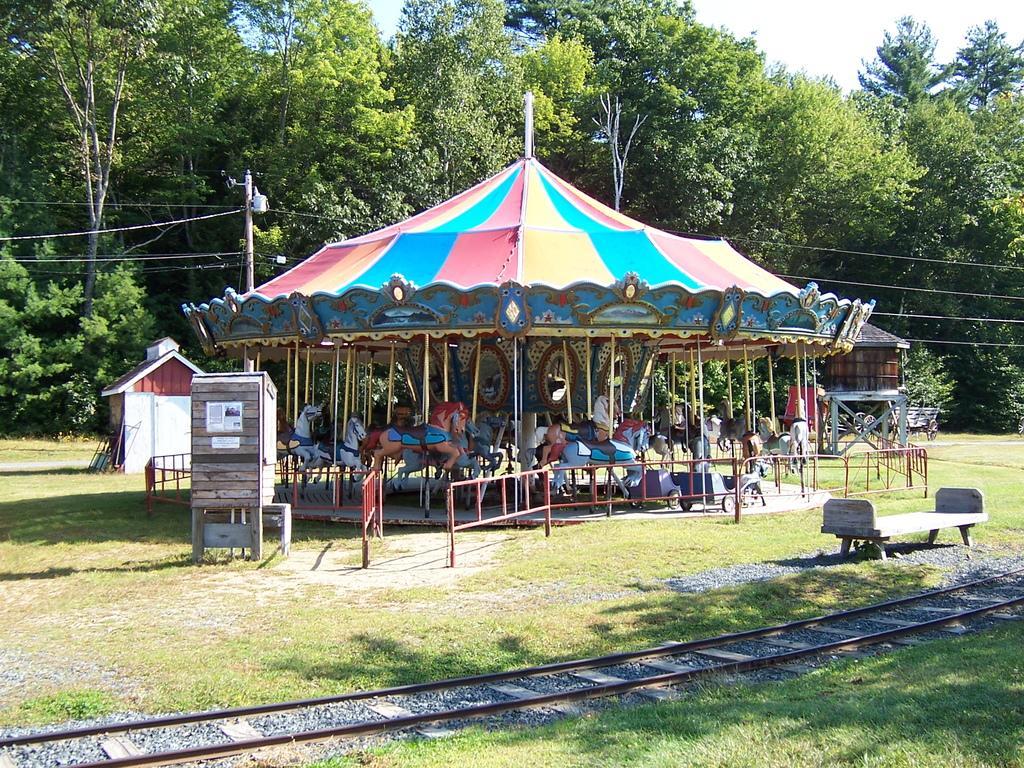Please provide a concise description of this image. In this image there is a child carousel, in the background there are trees, in front of the child carousel there is a bench and a track. 